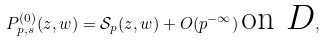<formula> <loc_0><loc_0><loc_500><loc_500>P _ { p , s } ^ { ( 0 ) } ( z , w ) = \mathcal { S } _ { p } ( z , w ) + O ( p ^ { - \infty } ) \, \text {on $D$} ,</formula> 